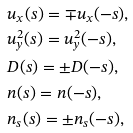Convert formula to latex. <formula><loc_0><loc_0><loc_500><loc_500>& u _ { x } ( s ) = \mp u _ { x } ( - s ) , \\ & u _ { y } ^ { 2 } ( s ) = u _ { y } ^ { 2 } ( - s ) , \\ & D ( s ) = \pm D ( - s ) , \\ & n ( s ) = n ( - s ) , \\ & n _ { s } ( s ) = \pm n _ { s } ( - s ) ,</formula> 